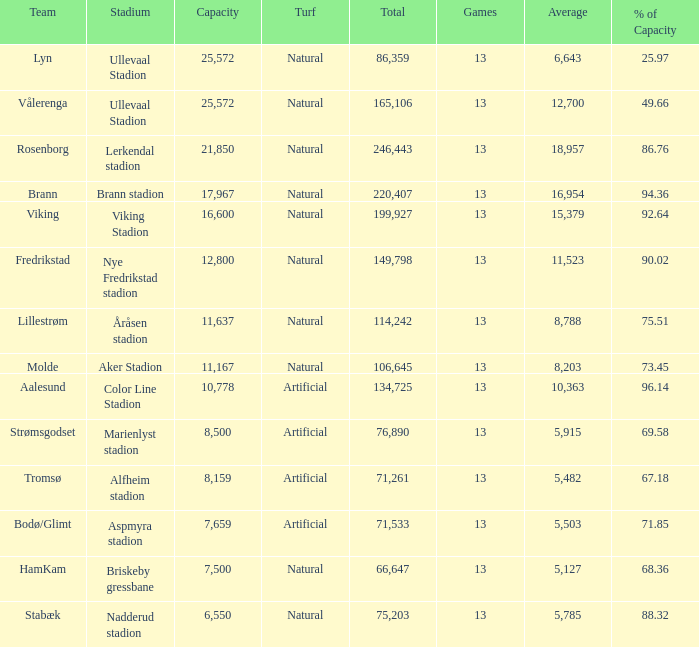What was the full turnout of aalesund with a capacity greater than 9 None. 